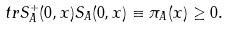<formula> <loc_0><loc_0><loc_500><loc_500>t r S _ { A } ^ { + } ( 0 , x ) S _ { A } ( 0 , x ) \equiv \pi _ { A } ( x ) \geq 0 .</formula> 